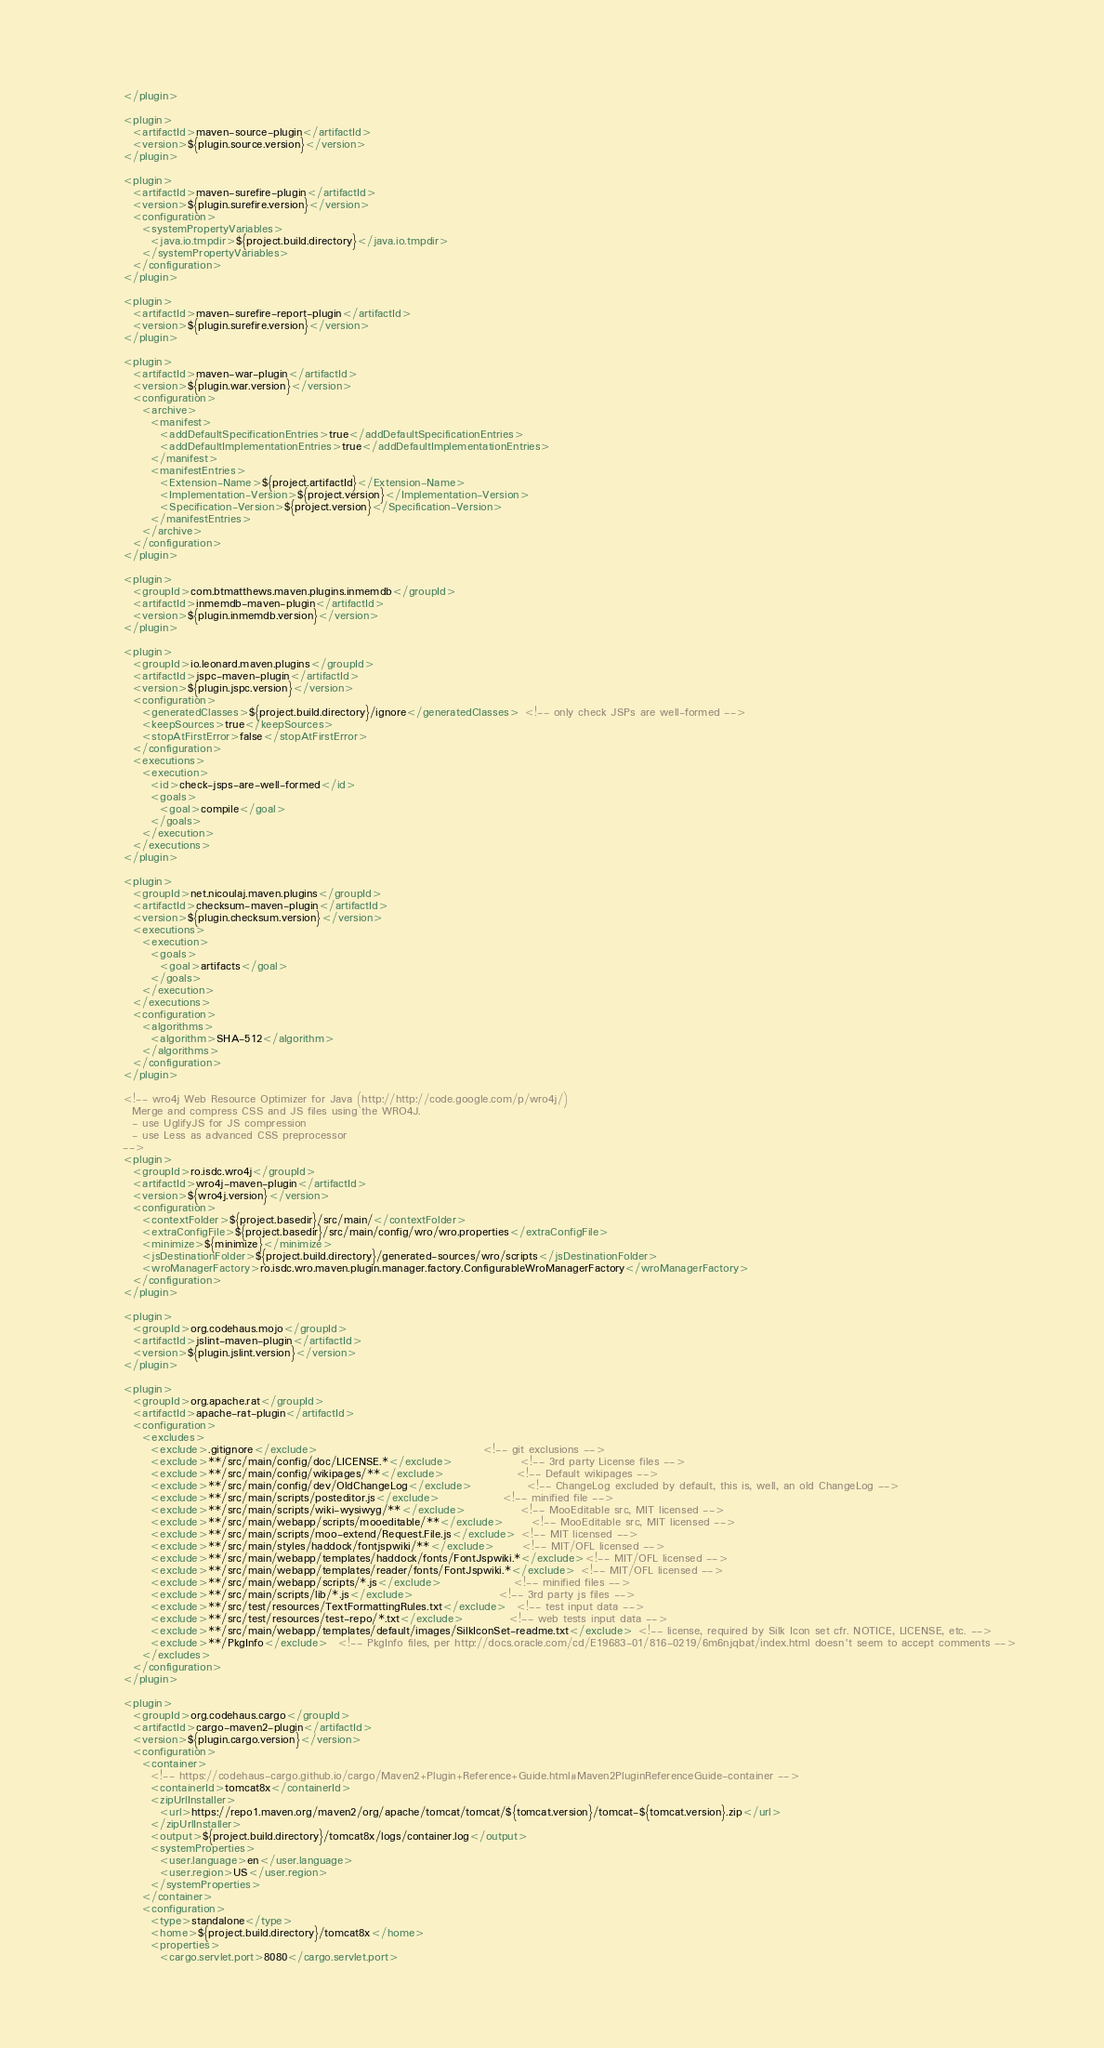Convert code to text. <code><loc_0><loc_0><loc_500><loc_500><_XML_>        </plugin>

        <plugin>
          <artifactId>maven-source-plugin</artifactId>
          <version>${plugin.source.version}</version>
        </plugin>

        <plugin>
          <artifactId>maven-surefire-plugin</artifactId>
          <version>${plugin.surefire.version}</version>
          <configuration>
            <systemPropertyVariables>
              <java.io.tmpdir>${project.build.directory}</java.io.tmpdir>
            </systemPropertyVariables>
          </configuration>
        </plugin>

        <plugin>
          <artifactId>maven-surefire-report-plugin</artifactId>
          <version>${plugin.surefire.version}</version>
        </plugin>

        <plugin>
          <artifactId>maven-war-plugin</artifactId>
          <version>${plugin.war.version}</version>
          <configuration>
            <archive>
              <manifest>
                <addDefaultSpecificationEntries>true</addDefaultSpecificationEntries>
                <addDefaultImplementationEntries>true</addDefaultImplementationEntries>
              </manifest>
              <manifestEntries>
                <Extension-Name>${project.artifactId}</Extension-Name>
                <Implementation-Version>${project.version}</Implementation-Version>
                <Specification-Version>${project.version}</Specification-Version>
              </manifestEntries>
            </archive>
          </configuration>
        </plugin>

        <plugin>
          <groupId>com.btmatthews.maven.plugins.inmemdb</groupId>
          <artifactId>inmemdb-maven-plugin</artifactId>
          <version>${plugin.inmemdb.version}</version>
        </plugin>

        <plugin>
          <groupId>io.leonard.maven.plugins</groupId>
          <artifactId>jspc-maven-plugin</artifactId>
          <version>${plugin.jspc.version}</version>
          <configuration>
            <generatedClasses>${project.build.directory}/ignore</generatedClasses> <!-- only check JSPs are well-formed -->
            <keepSources>true</keepSources>
            <stopAtFirstError>false</stopAtFirstError>
          </configuration>
          <executions>
            <execution>
              <id>check-jsps-are-well-formed</id>
              <goals>
                <goal>compile</goal>
              </goals>
            </execution>
          </executions>
        </plugin>

        <plugin>
          <groupId>net.nicoulaj.maven.plugins</groupId>
          <artifactId>checksum-maven-plugin</artifactId>
          <version>${plugin.checksum.version}</version>
          <executions>
            <execution>
              <goals>
                <goal>artifacts</goal>
              </goals>
            </execution>
          </executions>
          <configuration>
            <algorithms>
              <algorithm>SHA-512</algorithm>
            </algorithms>
          </configuration>
        </plugin>

        <!-- wro4j Web Resource Optimizer for Java (http://http://code.google.com/p/wro4j/)
          Merge and compress CSS and JS files using the WRO4J.
          - use UglifyJS for JS compression
          - use Less as advanced CSS preprocessor
        -->
        <plugin>
          <groupId>ro.isdc.wro4j</groupId>
          <artifactId>wro4j-maven-plugin</artifactId>
          <version>${wro4j.version}</version>
          <configuration>
            <contextFolder>${project.basedir}/src/main/</contextFolder>
            <extraConfigFile>${project.basedir}/src/main/config/wro/wro.properties</extraConfigFile>
            <minimize>${minimize}</minimize>
            <jsDestinationFolder>${project.build.directory}/generated-sources/wro/scripts</jsDestinationFolder>
            <wroManagerFactory>ro.isdc.wro.maven.plugin.manager.factory.ConfigurableWroManagerFactory</wroManagerFactory>
          </configuration>
        </plugin>

        <plugin>
          <groupId>org.codehaus.mojo</groupId>
          <artifactId>jslint-maven-plugin</artifactId>
          <version>${plugin.jslint.version}</version>
        </plugin>

        <plugin>
          <groupId>org.apache.rat</groupId>
          <artifactId>apache-rat-plugin</artifactId>
          <configuration>
            <excludes>
              <exclude>.gitignore</exclude>                                     <!-- git exclusions -->
              <exclude>**/src/main/config/doc/LICENSE.*</exclude>               <!-- 3rd party License files -->
              <exclude>**/src/main/config/wikipages/**</exclude>                <!-- Default wikipages -->
              <exclude>**/src/main/config/dev/OldChangeLog</exclude>            <!-- ChangeLog excluded by default, this is, well, an old ChangeLog -->
              <exclude>**/src/main/scripts/posteditor.js</exclude>              <!-- minified file -->
              <exclude>**/src/main/scripts/wiki-wysiwyg/**</exclude>            <!-- MooEditable src, MIT licensed -->
              <exclude>**/src/main/webapp/scripts/mooeditable/**</exclude>      <!-- MooEditable src, MIT licensed -->
              <exclude>**/src/main/scripts/moo-extend/Request.File.js</exclude> <!-- MIT licensed -->
              <exclude>**/src/main/styles/haddock/fontjspwiki/**</exclude>      <!-- MIT/OFL licensed -->
              <exclude>**/src/main/webapp/templates/haddock/fonts/FontJspwiki.*</exclude><!-- MIT/OFL licensed -->
              <exclude>**/src/main/webapp/templates/reader/fonts/FontJspwiki.*</exclude> <!-- MIT/OFL licensed -->
              <exclude>**/src/main/webapp/scripts/*.js</exclude>                <!-- minified files -->
              <exclude>**/src/main/scripts/lib/*.js</exclude>                   <!-- 3rd party js files -->
              <exclude>**/src/test/resources/TextFormattingRules.txt</exclude>  <!-- test input data -->
              <exclude>**/src/test/resources/test-repo/*.txt</exclude>          <!-- web tests input data -->
              <exclude>**/src/main/webapp/templates/default/images/SilkIconSet-readme.txt</exclude> <!-- license, required by Silk Icon set cfr. NOTICE, LICENSE, etc. -->
              <exclude>**/PkgInfo</exclude>  <!-- PkgInfo files, per http://docs.oracle.com/cd/E19683-01/816-0219/6m6njqbat/index.html doesn't seem to accept comments -->
            </excludes>
          </configuration>
        </plugin>

        <plugin>
          <groupId>org.codehaus.cargo</groupId>
          <artifactId>cargo-maven2-plugin</artifactId>
          <version>${plugin.cargo.version}</version>
          <configuration>
            <container>
              <!-- https://codehaus-cargo.github.io/cargo/Maven2+Plugin+Reference+Guide.html#Maven2PluginReferenceGuide-container -->
              <containerId>tomcat8x</containerId>
              <zipUrlInstaller>
                <url>https://repo1.maven.org/maven2/org/apache/tomcat/tomcat/${tomcat.version}/tomcat-${tomcat.version}.zip</url>
              </zipUrlInstaller>
              <output>${project.build.directory}/tomcat8x/logs/container.log</output>
              <systemProperties>
                <user.language>en</user.language>
                <user.region>US</user.region>
              </systemProperties>
            </container>
            <configuration>
              <type>standalone</type>
              <home>${project.build.directory}/tomcat8x</home>
              <properties>
                <cargo.servlet.port>8080</cargo.servlet.port></code> 